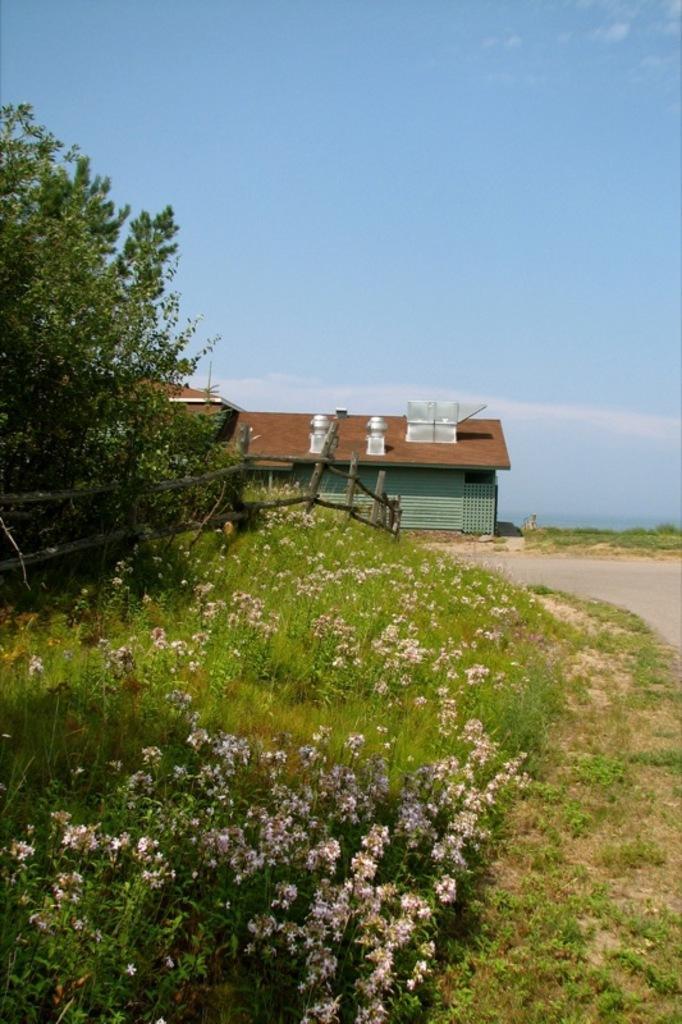Could you give a brief overview of what you see in this image? In this image I can see few flowers in white color. I can also see few plants and trees in green color. Background I can see the house and the sky is in blue color. 